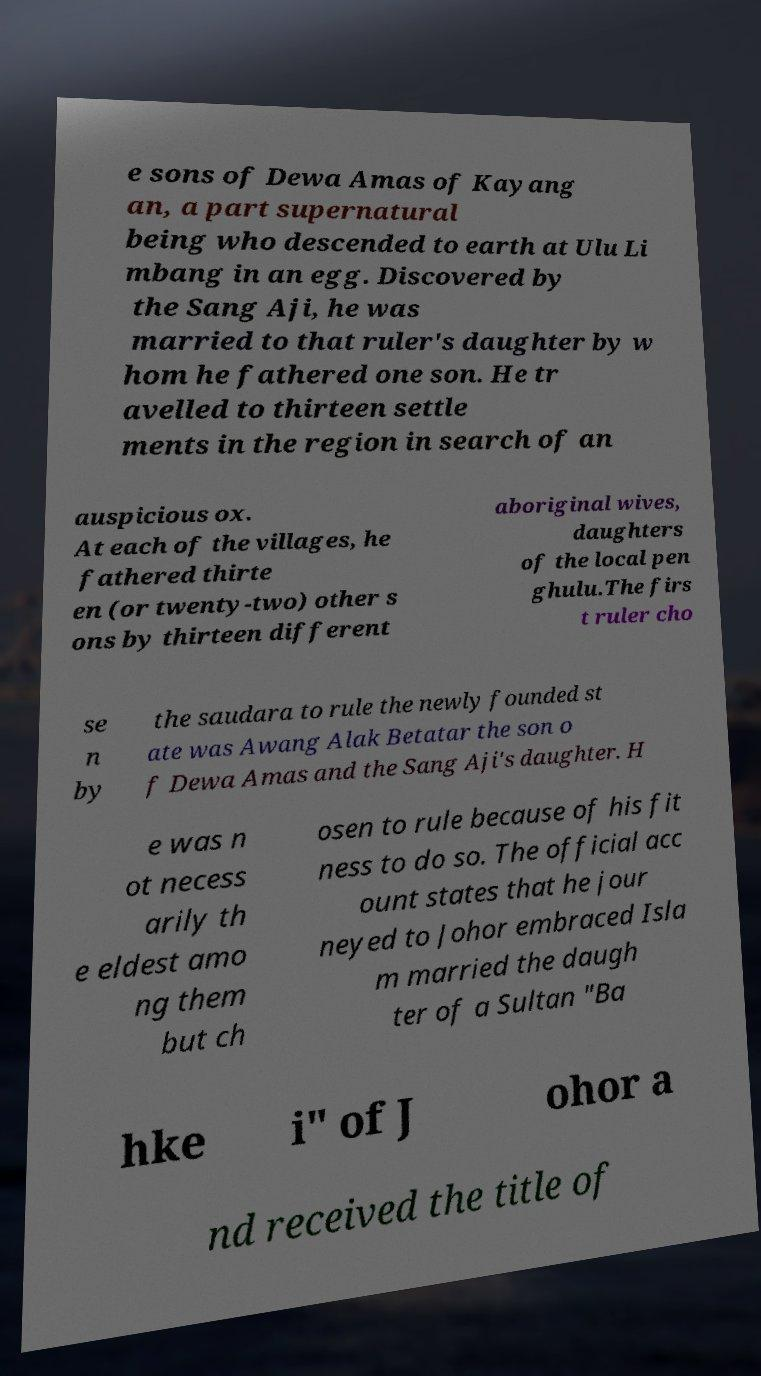I need the written content from this picture converted into text. Can you do that? e sons of Dewa Amas of Kayang an, a part supernatural being who descended to earth at Ulu Li mbang in an egg. Discovered by the Sang Aji, he was married to that ruler's daughter by w hom he fathered one son. He tr avelled to thirteen settle ments in the region in search of an auspicious ox. At each of the villages, he fathered thirte en (or twenty-two) other s ons by thirteen different aboriginal wives, daughters of the local pen ghulu.The firs t ruler cho se n by the saudara to rule the newly founded st ate was Awang Alak Betatar the son o f Dewa Amas and the Sang Aji's daughter. H e was n ot necess arily th e eldest amo ng them but ch osen to rule because of his fit ness to do so. The official acc ount states that he jour neyed to Johor embraced Isla m married the daugh ter of a Sultan "Ba hke i" of J ohor a nd received the title of 